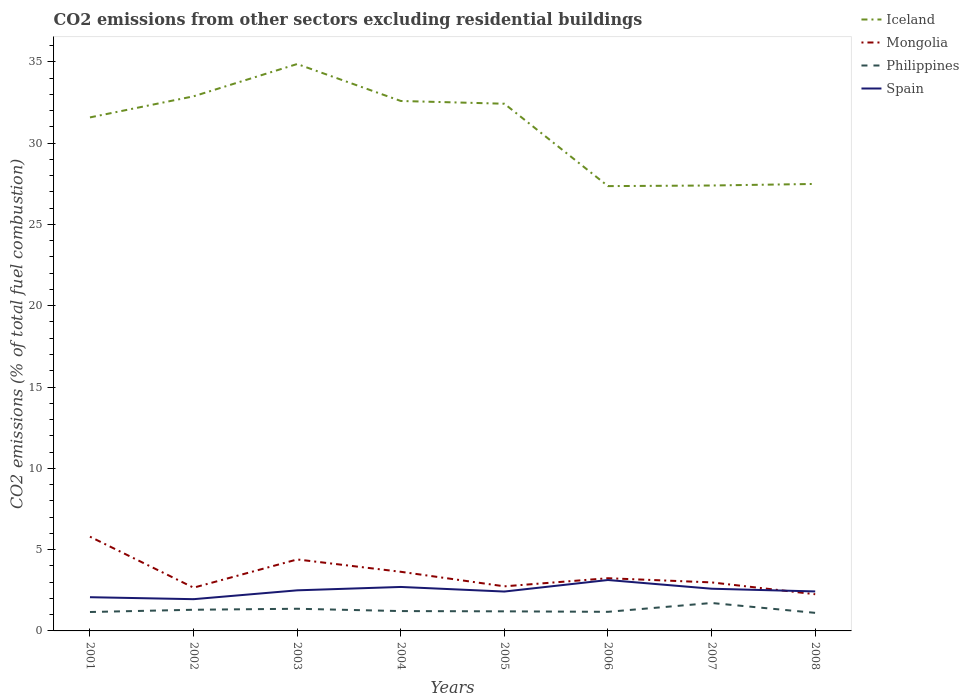How many different coloured lines are there?
Provide a short and direct response. 4. Does the line corresponding to Mongolia intersect with the line corresponding to Philippines?
Offer a terse response. No. Across all years, what is the maximum total CO2 emitted in Philippines?
Make the answer very short. 1.11. In which year was the total CO2 emitted in Philippines maximum?
Make the answer very short. 2008. What is the total total CO2 emitted in Philippines in the graph?
Provide a succinct answer. -0.51. What is the difference between the highest and the second highest total CO2 emitted in Iceland?
Your answer should be compact. 7.51. Is the total CO2 emitted in Spain strictly greater than the total CO2 emitted in Iceland over the years?
Give a very brief answer. Yes. How many lines are there?
Your response must be concise. 4. What is the difference between two consecutive major ticks on the Y-axis?
Give a very brief answer. 5. Does the graph contain any zero values?
Offer a terse response. No. Does the graph contain grids?
Provide a short and direct response. No. What is the title of the graph?
Give a very brief answer. CO2 emissions from other sectors excluding residential buildings. Does "Least developed countries" appear as one of the legend labels in the graph?
Provide a short and direct response. No. What is the label or title of the X-axis?
Your answer should be very brief. Years. What is the label or title of the Y-axis?
Your response must be concise. CO2 emissions (% of total fuel combustion). What is the CO2 emissions (% of total fuel combustion) of Iceland in 2001?
Offer a very short reply. 31.58. What is the CO2 emissions (% of total fuel combustion) of Mongolia in 2001?
Provide a succinct answer. 5.8. What is the CO2 emissions (% of total fuel combustion) in Philippines in 2001?
Keep it short and to the point. 1.16. What is the CO2 emissions (% of total fuel combustion) of Spain in 2001?
Provide a succinct answer. 2.07. What is the CO2 emissions (% of total fuel combustion) in Iceland in 2002?
Keep it short and to the point. 32.88. What is the CO2 emissions (% of total fuel combustion) in Mongolia in 2002?
Provide a short and direct response. 2.66. What is the CO2 emissions (% of total fuel combustion) in Philippines in 2002?
Give a very brief answer. 1.3. What is the CO2 emissions (% of total fuel combustion) in Spain in 2002?
Give a very brief answer. 1.95. What is the CO2 emissions (% of total fuel combustion) of Iceland in 2003?
Your answer should be compact. 34.86. What is the CO2 emissions (% of total fuel combustion) in Mongolia in 2003?
Keep it short and to the point. 4.4. What is the CO2 emissions (% of total fuel combustion) of Philippines in 2003?
Your answer should be compact. 1.36. What is the CO2 emissions (% of total fuel combustion) in Spain in 2003?
Ensure brevity in your answer.  2.5. What is the CO2 emissions (% of total fuel combustion) in Iceland in 2004?
Offer a terse response. 32.59. What is the CO2 emissions (% of total fuel combustion) of Mongolia in 2004?
Ensure brevity in your answer.  3.64. What is the CO2 emissions (% of total fuel combustion) in Philippines in 2004?
Your answer should be very brief. 1.22. What is the CO2 emissions (% of total fuel combustion) of Spain in 2004?
Provide a short and direct response. 2.7. What is the CO2 emissions (% of total fuel combustion) of Iceland in 2005?
Offer a terse response. 32.42. What is the CO2 emissions (% of total fuel combustion) in Mongolia in 2005?
Offer a very short reply. 2.74. What is the CO2 emissions (% of total fuel combustion) of Philippines in 2005?
Ensure brevity in your answer.  1.2. What is the CO2 emissions (% of total fuel combustion) of Spain in 2005?
Your answer should be very brief. 2.42. What is the CO2 emissions (% of total fuel combustion) in Iceland in 2006?
Give a very brief answer. 27.35. What is the CO2 emissions (% of total fuel combustion) of Mongolia in 2006?
Your answer should be very brief. 3.24. What is the CO2 emissions (% of total fuel combustion) of Philippines in 2006?
Keep it short and to the point. 1.17. What is the CO2 emissions (% of total fuel combustion) in Spain in 2006?
Your response must be concise. 3.13. What is the CO2 emissions (% of total fuel combustion) in Iceland in 2007?
Provide a short and direct response. 27.39. What is the CO2 emissions (% of total fuel combustion) in Mongolia in 2007?
Offer a terse response. 2.98. What is the CO2 emissions (% of total fuel combustion) in Philippines in 2007?
Offer a terse response. 1.72. What is the CO2 emissions (% of total fuel combustion) in Spain in 2007?
Your response must be concise. 2.6. What is the CO2 emissions (% of total fuel combustion) of Iceland in 2008?
Give a very brief answer. 27.49. What is the CO2 emissions (% of total fuel combustion) in Mongolia in 2008?
Provide a short and direct response. 2.26. What is the CO2 emissions (% of total fuel combustion) in Philippines in 2008?
Your answer should be compact. 1.11. What is the CO2 emissions (% of total fuel combustion) in Spain in 2008?
Give a very brief answer. 2.43. Across all years, what is the maximum CO2 emissions (% of total fuel combustion) in Iceland?
Offer a very short reply. 34.86. Across all years, what is the maximum CO2 emissions (% of total fuel combustion) of Mongolia?
Provide a succinct answer. 5.8. Across all years, what is the maximum CO2 emissions (% of total fuel combustion) in Philippines?
Your answer should be compact. 1.72. Across all years, what is the maximum CO2 emissions (% of total fuel combustion) in Spain?
Your response must be concise. 3.13. Across all years, what is the minimum CO2 emissions (% of total fuel combustion) in Iceland?
Offer a very short reply. 27.35. Across all years, what is the minimum CO2 emissions (% of total fuel combustion) in Mongolia?
Offer a terse response. 2.26. Across all years, what is the minimum CO2 emissions (% of total fuel combustion) in Philippines?
Keep it short and to the point. 1.11. Across all years, what is the minimum CO2 emissions (% of total fuel combustion) of Spain?
Your answer should be very brief. 1.95. What is the total CO2 emissions (% of total fuel combustion) in Iceland in the graph?
Your response must be concise. 246.56. What is the total CO2 emissions (% of total fuel combustion) of Mongolia in the graph?
Your answer should be very brief. 27.71. What is the total CO2 emissions (% of total fuel combustion) of Philippines in the graph?
Keep it short and to the point. 10.26. What is the total CO2 emissions (% of total fuel combustion) of Spain in the graph?
Your answer should be compact. 19.8. What is the difference between the CO2 emissions (% of total fuel combustion) of Iceland in 2001 and that in 2002?
Keep it short and to the point. -1.3. What is the difference between the CO2 emissions (% of total fuel combustion) of Mongolia in 2001 and that in 2002?
Your response must be concise. 3.14. What is the difference between the CO2 emissions (% of total fuel combustion) in Philippines in 2001 and that in 2002?
Provide a succinct answer. -0.14. What is the difference between the CO2 emissions (% of total fuel combustion) in Spain in 2001 and that in 2002?
Your response must be concise. 0.12. What is the difference between the CO2 emissions (% of total fuel combustion) in Iceland in 2001 and that in 2003?
Your response must be concise. -3.28. What is the difference between the CO2 emissions (% of total fuel combustion) in Mongolia in 2001 and that in 2003?
Your response must be concise. 1.4. What is the difference between the CO2 emissions (% of total fuel combustion) in Philippines in 2001 and that in 2003?
Give a very brief answer. -0.2. What is the difference between the CO2 emissions (% of total fuel combustion) of Spain in 2001 and that in 2003?
Ensure brevity in your answer.  -0.42. What is the difference between the CO2 emissions (% of total fuel combustion) in Iceland in 2001 and that in 2004?
Provide a short and direct response. -1.01. What is the difference between the CO2 emissions (% of total fuel combustion) in Mongolia in 2001 and that in 2004?
Give a very brief answer. 2.16. What is the difference between the CO2 emissions (% of total fuel combustion) in Philippines in 2001 and that in 2004?
Provide a succinct answer. -0.06. What is the difference between the CO2 emissions (% of total fuel combustion) of Spain in 2001 and that in 2004?
Your answer should be very brief. -0.63. What is the difference between the CO2 emissions (% of total fuel combustion) of Iceland in 2001 and that in 2005?
Offer a very short reply. -0.84. What is the difference between the CO2 emissions (% of total fuel combustion) in Mongolia in 2001 and that in 2005?
Make the answer very short. 3.05. What is the difference between the CO2 emissions (% of total fuel combustion) in Philippines in 2001 and that in 2005?
Provide a succinct answer. -0.04. What is the difference between the CO2 emissions (% of total fuel combustion) of Spain in 2001 and that in 2005?
Your answer should be very brief. -0.35. What is the difference between the CO2 emissions (% of total fuel combustion) of Iceland in 2001 and that in 2006?
Your answer should be compact. 4.22. What is the difference between the CO2 emissions (% of total fuel combustion) of Mongolia in 2001 and that in 2006?
Make the answer very short. 2.55. What is the difference between the CO2 emissions (% of total fuel combustion) in Philippines in 2001 and that in 2006?
Your answer should be compact. -0.01. What is the difference between the CO2 emissions (% of total fuel combustion) of Spain in 2001 and that in 2006?
Offer a very short reply. -1.06. What is the difference between the CO2 emissions (% of total fuel combustion) in Iceland in 2001 and that in 2007?
Give a very brief answer. 4.19. What is the difference between the CO2 emissions (% of total fuel combustion) of Mongolia in 2001 and that in 2007?
Your response must be concise. 2.81. What is the difference between the CO2 emissions (% of total fuel combustion) in Philippines in 2001 and that in 2007?
Offer a terse response. -0.55. What is the difference between the CO2 emissions (% of total fuel combustion) in Spain in 2001 and that in 2007?
Your response must be concise. -0.52. What is the difference between the CO2 emissions (% of total fuel combustion) in Iceland in 2001 and that in 2008?
Give a very brief answer. 4.09. What is the difference between the CO2 emissions (% of total fuel combustion) in Mongolia in 2001 and that in 2008?
Provide a succinct answer. 3.54. What is the difference between the CO2 emissions (% of total fuel combustion) in Philippines in 2001 and that in 2008?
Provide a succinct answer. 0.05. What is the difference between the CO2 emissions (% of total fuel combustion) in Spain in 2001 and that in 2008?
Provide a succinct answer. -0.35. What is the difference between the CO2 emissions (% of total fuel combustion) of Iceland in 2002 and that in 2003?
Offer a terse response. -1.99. What is the difference between the CO2 emissions (% of total fuel combustion) in Mongolia in 2002 and that in 2003?
Offer a very short reply. -1.74. What is the difference between the CO2 emissions (% of total fuel combustion) of Philippines in 2002 and that in 2003?
Your response must be concise. -0.06. What is the difference between the CO2 emissions (% of total fuel combustion) of Spain in 2002 and that in 2003?
Your response must be concise. -0.54. What is the difference between the CO2 emissions (% of total fuel combustion) of Iceland in 2002 and that in 2004?
Keep it short and to the point. 0.29. What is the difference between the CO2 emissions (% of total fuel combustion) in Mongolia in 2002 and that in 2004?
Offer a very short reply. -0.98. What is the difference between the CO2 emissions (% of total fuel combustion) of Philippines in 2002 and that in 2004?
Your answer should be very brief. 0.08. What is the difference between the CO2 emissions (% of total fuel combustion) in Spain in 2002 and that in 2004?
Give a very brief answer. -0.75. What is the difference between the CO2 emissions (% of total fuel combustion) of Iceland in 2002 and that in 2005?
Ensure brevity in your answer.  0.46. What is the difference between the CO2 emissions (% of total fuel combustion) in Mongolia in 2002 and that in 2005?
Give a very brief answer. -0.08. What is the difference between the CO2 emissions (% of total fuel combustion) in Philippines in 2002 and that in 2005?
Keep it short and to the point. 0.1. What is the difference between the CO2 emissions (% of total fuel combustion) in Spain in 2002 and that in 2005?
Give a very brief answer. -0.47. What is the difference between the CO2 emissions (% of total fuel combustion) of Iceland in 2002 and that in 2006?
Your response must be concise. 5.52. What is the difference between the CO2 emissions (% of total fuel combustion) of Mongolia in 2002 and that in 2006?
Your answer should be compact. -0.58. What is the difference between the CO2 emissions (% of total fuel combustion) in Philippines in 2002 and that in 2006?
Offer a very short reply. 0.13. What is the difference between the CO2 emissions (% of total fuel combustion) in Spain in 2002 and that in 2006?
Offer a very short reply. -1.18. What is the difference between the CO2 emissions (% of total fuel combustion) in Iceland in 2002 and that in 2007?
Your answer should be very brief. 5.49. What is the difference between the CO2 emissions (% of total fuel combustion) of Mongolia in 2002 and that in 2007?
Provide a short and direct response. -0.32. What is the difference between the CO2 emissions (% of total fuel combustion) in Philippines in 2002 and that in 2007?
Ensure brevity in your answer.  -0.42. What is the difference between the CO2 emissions (% of total fuel combustion) of Spain in 2002 and that in 2007?
Keep it short and to the point. -0.64. What is the difference between the CO2 emissions (% of total fuel combustion) of Iceland in 2002 and that in 2008?
Give a very brief answer. 5.39. What is the difference between the CO2 emissions (% of total fuel combustion) in Mongolia in 2002 and that in 2008?
Provide a short and direct response. 0.4. What is the difference between the CO2 emissions (% of total fuel combustion) of Philippines in 2002 and that in 2008?
Keep it short and to the point. 0.19. What is the difference between the CO2 emissions (% of total fuel combustion) in Spain in 2002 and that in 2008?
Your response must be concise. -0.48. What is the difference between the CO2 emissions (% of total fuel combustion) of Iceland in 2003 and that in 2004?
Provide a succinct answer. 2.27. What is the difference between the CO2 emissions (% of total fuel combustion) of Mongolia in 2003 and that in 2004?
Provide a succinct answer. 0.76. What is the difference between the CO2 emissions (% of total fuel combustion) of Philippines in 2003 and that in 2004?
Provide a short and direct response. 0.14. What is the difference between the CO2 emissions (% of total fuel combustion) of Spain in 2003 and that in 2004?
Your response must be concise. -0.21. What is the difference between the CO2 emissions (% of total fuel combustion) in Iceland in 2003 and that in 2005?
Give a very brief answer. 2.44. What is the difference between the CO2 emissions (% of total fuel combustion) of Mongolia in 2003 and that in 2005?
Your answer should be compact. 1.65. What is the difference between the CO2 emissions (% of total fuel combustion) in Philippines in 2003 and that in 2005?
Give a very brief answer. 0.16. What is the difference between the CO2 emissions (% of total fuel combustion) of Spain in 2003 and that in 2005?
Provide a succinct answer. 0.07. What is the difference between the CO2 emissions (% of total fuel combustion) in Iceland in 2003 and that in 2006?
Provide a succinct answer. 7.51. What is the difference between the CO2 emissions (% of total fuel combustion) in Mongolia in 2003 and that in 2006?
Give a very brief answer. 1.15. What is the difference between the CO2 emissions (% of total fuel combustion) of Philippines in 2003 and that in 2006?
Make the answer very short. 0.19. What is the difference between the CO2 emissions (% of total fuel combustion) in Spain in 2003 and that in 2006?
Your answer should be compact. -0.63. What is the difference between the CO2 emissions (% of total fuel combustion) of Iceland in 2003 and that in 2007?
Your answer should be very brief. 7.47. What is the difference between the CO2 emissions (% of total fuel combustion) of Mongolia in 2003 and that in 2007?
Offer a terse response. 1.41. What is the difference between the CO2 emissions (% of total fuel combustion) of Philippines in 2003 and that in 2007?
Keep it short and to the point. -0.35. What is the difference between the CO2 emissions (% of total fuel combustion) of Spain in 2003 and that in 2007?
Your response must be concise. -0.1. What is the difference between the CO2 emissions (% of total fuel combustion) in Iceland in 2003 and that in 2008?
Offer a terse response. 7.37. What is the difference between the CO2 emissions (% of total fuel combustion) in Mongolia in 2003 and that in 2008?
Your answer should be very brief. 2.14. What is the difference between the CO2 emissions (% of total fuel combustion) of Philippines in 2003 and that in 2008?
Make the answer very short. 0.25. What is the difference between the CO2 emissions (% of total fuel combustion) of Spain in 2003 and that in 2008?
Your response must be concise. 0.07. What is the difference between the CO2 emissions (% of total fuel combustion) in Iceland in 2004 and that in 2005?
Provide a short and direct response. 0.17. What is the difference between the CO2 emissions (% of total fuel combustion) in Mongolia in 2004 and that in 2005?
Your response must be concise. 0.89. What is the difference between the CO2 emissions (% of total fuel combustion) in Philippines in 2004 and that in 2005?
Your answer should be very brief. 0.02. What is the difference between the CO2 emissions (% of total fuel combustion) in Spain in 2004 and that in 2005?
Give a very brief answer. 0.28. What is the difference between the CO2 emissions (% of total fuel combustion) of Iceland in 2004 and that in 2006?
Provide a short and direct response. 5.24. What is the difference between the CO2 emissions (% of total fuel combustion) of Mongolia in 2004 and that in 2006?
Ensure brevity in your answer.  0.4. What is the difference between the CO2 emissions (% of total fuel combustion) in Philippines in 2004 and that in 2006?
Give a very brief answer. 0.05. What is the difference between the CO2 emissions (% of total fuel combustion) in Spain in 2004 and that in 2006?
Give a very brief answer. -0.43. What is the difference between the CO2 emissions (% of total fuel combustion) of Iceland in 2004 and that in 2007?
Provide a succinct answer. 5.2. What is the difference between the CO2 emissions (% of total fuel combustion) in Mongolia in 2004 and that in 2007?
Your answer should be very brief. 0.65. What is the difference between the CO2 emissions (% of total fuel combustion) in Philippines in 2004 and that in 2007?
Provide a short and direct response. -0.5. What is the difference between the CO2 emissions (% of total fuel combustion) in Spain in 2004 and that in 2007?
Give a very brief answer. 0.11. What is the difference between the CO2 emissions (% of total fuel combustion) in Iceland in 2004 and that in 2008?
Ensure brevity in your answer.  5.1. What is the difference between the CO2 emissions (% of total fuel combustion) in Mongolia in 2004 and that in 2008?
Your answer should be compact. 1.38. What is the difference between the CO2 emissions (% of total fuel combustion) in Philippines in 2004 and that in 2008?
Provide a short and direct response. 0.11. What is the difference between the CO2 emissions (% of total fuel combustion) in Spain in 2004 and that in 2008?
Offer a terse response. 0.28. What is the difference between the CO2 emissions (% of total fuel combustion) of Iceland in 2005 and that in 2006?
Give a very brief answer. 5.07. What is the difference between the CO2 emissions (% of total fuel combustion) in Mongolia in 2005 and that in 2006?
Keep it short and to the point. -0.5. What is the difference between the CO2 emissions (% of total fuel combustion) of Philippines in 2005 and that in 2006?
Make the answer very short. 0.03. What is the difference between the CO2 emissions (% of total fuel combustion) of Spain in 2005 and that in 2006?
Give a very brief answer. -0.71. What is the difference between the CO2 emissions (% of total fuel combustion) of Iceland in 2005 and that in 2007?
Your answer should be compact. 5.03. What is the difference between the CO2 emissions (% of total fuel combustion) of Mongolia in 2005 and that in 2007?
Keep it short and to the point. -0.24. What is the difference between the CO2 emissions (% of total fuel combustion) of Philippines in 2005 and that in 2007?
Your answer should be very brief. -0.51. What is the difference between the CO2 emissions (% of total fuel combustion) of Spain in 2005 and that in 2007?
Keep it short and to the point. -0.17. What is the difference between the CO2 emissions (% of total fuel combustion) in Iceland in 2005 and that in 2008?
Ensure brevity in your answer.  4.93. What is the difference between the CO2 emissions (% of total fuel combustion) in Mongolia in 2005 and that in 2008?
Provide a short and direct response. 0.49. What is the difference between the CO2 emissions (% of total fuel combustion) in Philippines in 2005 and that in 2008?
Your answer should be very brief. 0.09. What is the difference between the CO2 emissions (% of total fuel combustion) of Spain in 2005 and that in 2008?
Provide a succinct answer. -0.01. What is the difference between the CO2 emissions (% of total fuel combustion) of Iceland in 2006 and that in 2007?
Your answer should be very brief. -0.04. What is the difference between the CO2 emissions (% of total fuel combustion) of Mongolia in 2006 and that in 2007?
Your response must be concise. 0.26. What is the difference between the CO2 emissions (% of total fuel combustion) in Philippines in 2006 and that in 2007?
Offer a very short reply. -0.54. What is the difference between the CO2 emissions (% of total fuel combustion) of Spain in 2006 and that in 2007?
Keep it short and to the point. 0.54. What is the difference between the CO2 emissions (% of total fuel combustion) of Iceland in 2006 and that in 2008?
Your answer should be very brief. -0.13. What is the difference between the CO2 emissions (% of total fuel combustion) in Mongolia in 2006 and that in 2008?
Ensure brevity in your answer.  0.98. What is the difference between the CO2 emissions (% of total fuel combustion) in Philippines in 2006 and that in 2008?
Keep it short and to the point. 0.06. What is the difference between the CO2 emissions (% of total fuel combustion) of Spain in 2006 and that in 2008?
Your answer should be compact. 0.7. What is the difference between the CO2 emissions (% of total fuel combustion) in Iceland in 2007 and that in 2008?
Offer a very short reply. -0.1. What is the difference between the CO2 emissions (% of total fuel combustion) in Mongolia in 2007 and that in 2008?
Provide a short and direct response. 0.73. What is the difference between the CO2 emissions (% of total fuel combustion) in Philippines in 2007 and that in 2008?
Keep it short and to the point. 0.61. What is the difference between the CO2 emissions (% of total fuel combustion) of Spain in 2007 and that in 2008?
Give a very brief answer. 0.17. What is the difference between the CO2 emissions (% of total fuel combustion) in Iceland in 2001 and the CO2 emissions (% of total fuel combustion) in Mongolia in 2002?
Your answer should be very brief. 28.92. What is the difference between the CO2 emissions (% of total fuel combustion) in Iceland in 2001 and the CO2 emissions (% of total fuel combustion) in Philippines in 2002?
Provide a succinct answer. 30.28. What is the difference between the CO2 emissions (% of total fuel combustion) of Iceland in 2001 and the CO2 emissions (% of total fuel combustion) of Spain in 2002?
Make the answer very short. 29.63. What is the difference between the CO2 emissions (% of total fuel combustion) of Mongolia in 2001 and the CO2 emissions (% of total fuel combustion) of Philippines in 2002?
Make the answer very short. 4.49. What is the difference between the CO2 emissions (% of total fuel combustion) of Mongolia in 2001 and the CO2 emissions (% of total fuel combustion) of Spain in 2002?
Offer a very short reply. 3.84. What is the difference between the CO2 emissions (% of total fuel combustion) in Philippines in 2001 and the CO2 emissions (% of total fuel combustion) in Spain in 2002?
Your answer should be compact. -0.79. What is the difference between the CO2 emissions (% of total fuel combustion) of Iceland in 2001 and the CO2 emissions (% of total fuel combustion) of Mongolia in 2003?
Offer a very short reply. 27.18. What is the difference between the CO2 emissions (% of total fuel combustion) of Iceland in 2001 and the CO2 emissions (% of total fuel combustion) of Philippines in 2003?
Your answer should be compact. 30.22. What is the difference between the CO2 emissions (% of total fuel combustion) in Iceland in 2001 and the CO2 emissions (% of total fuel combustion) in Spain in 2003?
Ensure brevity in your answer.  29.08. What is the difference between the CO2 emissions (% of total fuel combustion) of Mongolia in 2001 and the CO2 emissions (% of total fuel combustion) of Philippines in 2003?
Make the answer very short. 4.43. What is the difference between the CO2 emissions (% of total fuel combustion) in Mongolia in 2001 and the CO2 emissions (% of total fuel combustion) in Spain in 2003?
Ensure brevity in your answer.  3.3. What is the difference between the CO2 emissions (% of total fuel combustion) in Philippines in 2001 and the CO2 emissions (% of total fuel combustion) in Spain in 2003?
Keep it short and to the point. -1.33. What is the difference between the CO2 emissions (% of total fuel combustion) of Iceland in 2001 and the CO2 emissions (% of total fuel combustion) of Mongolia in 2004?
Give a very brief answer. 27.94. What is the difference between the CO2 emissions (% of total fuel combustion) in Iceland in 2001 and the CO2 emissions (% of total fuel combustion) in Philippines in 2004?
Your answer should be very brief. 30.36. What is the difference between the CO2 emissions (% of total fuel combustion) in Iceland in 2001 and the CO2 emissions (% of total fuel combustion) in Spain in 2004?
Your answer should be compact. 28.87. What is the difference between the CO2 emissions (% of total fuel combustion) in Mongolia in 2001 and the CO2 emissions (% of total fuel combustion) in Philippines in 2004?
Provide a succinct answer. 4.57. What is the difference between the CO2 emissions (% of total fuel combustion) in Mongolia in 2001 and the CO2 emissions (% of total fuel combustion) in Spain in 2004?
Provide a succinct answer. 3.09. What is the difference between the CO2 emissions (% of total fuel combustion) in Philippines in 2001 and the CO2 emissions (% of total fuel combustion) in Spain in 2004?
Give a very brief answer. -1.54. What is the difference between the CO2 emissions (% of total fuel combustion) of Iceland in 2001 and the CO2 emissions (% of total fuel combustion) of Mongolia in 2005?
Your answer should be compact. 28.84. What is the difference between the CO2 emissions (% of total fuel combustion) in Iceland in 2001 and the CO2 emissions (% of total fuel combustion) in Philippines in 2005?
Offer a very short reply. 30.37. What is the difference between the CO2 emissions (% of total fuel combustion) in Iceland in 2001 and the CO2 emissions (% of total fuel combustion) in Spain in 2005?
Your response must be concise. 29.16. What is the difference between the CO2 emissions (% of total fuel combustion) of Mongolia in 2001 and the CO2 emissions (% of total fuel combustion) of Philippines in 2005?
Your answer should be very brief. 4.59. What is the difference between the CO2 emissions (% of total fuel combustion) in Mongolia in 2001 and the CO2 emissions (% of total fuel combustion) in Spain in 2005?
Provide a succinct answer. 3.37. What is the difference between the CO2 emissions (% of total fuel combustion) in Philippines in 2001 and the CO2 emissions (% of total fuel combustion) in Spain in 2005?
Make the answer very short. -1.26. What is the difference between the CO2 emissions (% of total fuel combustion) in Iceland in 2001 and the CO2 emissions (% of total fuel combustion) in Mongolia in 2006?
Offer a terse response. 28.34. What is the difference between the CO2 emissions (% of total fuel combustion) of Iceland in 2001 and the CO2 emissions (% of total fuel combustion) of Philippines in 2006?
Offer a very short reply. 30.4. What is the difference between the CO2 emissions (% of total fuel combustion) of Iceland in 2001 and the CO2 emissions (% of total fuel combustion) of Spain in 2006?
Your response must be concise. 28.45. What is the difference between the CO2 emissions (% of total fuel combustion) of Mongolia in 2001 and the CO2 emissions (% of total fuel combustion) of Philippines in 2006?
Your answer should be very brief. 4.62. What is the difference between the CO2 emissions (% of total fuel combustion) of Mongolia in 2001 and the CO2 emissions (% of total fuel combustion) of Spain in 2006?
Your answer should be compact. 2.66. What is the difference between the CO2 emissions (% of total fuel combustion) in Philippines in 2001 and the CO2 emissions (% of total fuel combustion) in Spain in 2006?
Your response must be concise. -1.97. What is the difference between the CO2 emissions (% of total fuel combustion) of Iceland in 2001 and the CO2 emissions (% of total fuel combustion) of Mongolia in 2007?
Your answer should be very brief. 28.6. What is the difference between the CO2 emissions (% of total fuel combustion) in Iceland in 2001 and the CO2 emissions (% of total fuel combustion) in Philippines in 2007?
Your response must be concise. 29.86. What is the difference between the CO2 emissions (% of total fuel combustion) of Iceland in 2001 and the CO2 emissions (% of total fuel combustion) of Spain in 2007?
Offer a very short reply. 28.98. What is the difference between the CO2 emissions (% of total fuel combustion) of Mongolia in 2001 and the CO2 emissions (% of total fuel combustion) of Philippines in 2007?
Keep it short and to the point. 4.08. What is the difference between the CO2 emissions (% of total fuel combustion) in Mongolia in 2001 and the CO2 emissions (% of total fuel combustion) in Spain in 2007?
Make the answer very short. 3.2. What is the difference between the CO2 emissions (% of total fuel combustion) in Philippines in 2001 and the CO2 emissions (% of total fuel combustion) in Spain in 2007?
Your response must be concise. -1.43. What is the difference between the CO2 emissions (% of total fuel combustion) of Iceland in 2001 and the CO2 emissions (% of total fuel combustion) of Mongolia in 2008?
Your response must be concise. 29.32. What is the difference between the CO2 emissions (% of total fuel combustion) of Iceland in 2001 and the CO2 emissions (% of total fuel combustion) of Philippines in 2008?
Offer a terse response. 30.47. What is the difference between the CO2 emissions (% of total fuel combustion) in Iceland in 2001 and the CO2 emissions (% of total fuel combustion) in Spain in 2008?
Your answer should be compact. 29.15. What is the difference between the CO2 emissions (% of total fuel combustion) of Mongolia in 2001 and the CO2 emissions (% of total fuel combustion) of Philippines in 2008?
Your answer should be compact. 4.68. What is the difference between the CO2 emissions (% of total fuel combustion) in Mongolia in 2001 and the CO2 emissions (% of total fuel combustion) in Spain in 2008?
Your answer should be compact. 3.37. What is the difference between the CO2 emissions (% of total fuel combustion) of Philippines in 2001 and the CO2 emissions (% of total fuel combustion) of Spain in 2008?
Give a very brief answer. -1.26. What is the difference between the CO2 emissions (% of total fuel combustion) of Iceland in 2002 and the CO2 emissions (% of total fuel combustion) of Mongolia in 2003?
Your answer should be very brief. 28.48. What is the difference between the CO2 emissions (% of total fuel combustion) in Iceland in 2002 and the CO2 emissions (% of total fuel combustion) in Philippines in 2003?
Give a very brief answer. 31.51. What is the difference between the CO2 emissions (% of total fuel combustion) of Iceland in 2002 and the CO2 emissions (% of total fuel combustion) of Spain in 2003?
Your response must be concise. 30.38. What is the difference between the CO2 emissions (% of total fuel combustion) in Mongolia in 2002 and the CO2 emissions (% of total fuel combustion) in Philippines in 2003?
Give a very brief answer. 1.3. What is the difference between the CO2 emissions (% of total fuel combustion) of Mongolia in 2002 and the CO2 emissions (% of total fuel combustion) of Spain in 2003?
Offer a very short reply. 0.16. What is the difference between the CO2 emissions (% of total fuel combustion) of Philippines in 2002 and the CO2 emissions (% of total fuel combustion) of Spain in 2003?
Your answer should be compact. -1.19. What is the difference between the CO2 emissions (% of total fuel combustion) in Iceland in 2002 and the CO2 emissions (% of total fuel combustion) in Mongolia in 2004?
Your answer should be compact. 29.24. What is the difference between the CO2 emissions (% of total fuel combustion) in Iceland in 2002 and the CO2 emissions (% of total fuel combustion) in Philippines in 2004?
Give a very brief answer. 31.66. What is the difference between the CO2 emissions (% of total fuel combustion) in Iceland in 2002 and the CO2 emissions (% of total fuel combustion) in Spain in 2004?
Ensure brevity in your answer.  30.17. What is the difference between the CO2 emissions (% of total fuel combustion) of Mongolia in 2002 and the CO2 emissions (% of total fuel combustion) of Philippines in 2004?
Offer a terse response. 1.44. What is the difference between the CO2 emissions (% of total fuel combustion) of Mongolia in 2002 and the CO2 emissions (% of total fuel combustion) of Spain in 2004?
Provide a succinct answer. -0.04. What is the difference between the CO2 emissions (% of total fuel combustion) in Philippines in 2002 and the CO2 emissions (% of total fuel combustion) in Spain in 2004?
Your answer should be very brief. -1.4. What is the difference between the CO2 emissions (% of total fuel combustion) of Iceland in 2002 and the CO2 emissions (% of total fuel combustion) of Mongolia in 2005?
Give a very brief answer. 30.13. What is the difference between the CO2 emissions (% of total fuel combustion) in Iceland in 2002 and the CO2 emissions (% of total fuel combustion) in Philippines in 2005?
Your answer should be compact. 31.67. What is the difference between the CO2 emissions (% of total fuel combustion) of Iceland in 2002 and the CO2 emissions (% of total fuel combustion) of Spain in 2005?
Offer a very short reply. 30.46. What is the difference between the CO2 emissions (% of total fuel combustion) in Mongolia in 2002 and the CO2 emissions (% of total fuel combustion) in Philippines in 2005?
Provide a succinct answer. 1.46. What is the difference between the CO2 emissions (% of total fuel combustion) in Mongolia in 2002 and the CO2 emissions (% of total fuel combustion) in Spain in 2005?
Provide a short and direct response. 0.24. What is the difference between the CO2 emissions (% of total fuel combustion) in Philippines in 2002 and the CO2 emissions (% of total fuel combustion) in Spain in 2005?
Provide a short and direct response. -1.12. What is the difference between the CO2 emissions (% of total fuel combustion) in Iceland in 2002 and the CO2 emissions (% of total fuel combustion) in Mongolia in 2006?
Provide a succinct answer. 29.64. What is the difference between the CO2 emissions (% of total fuel combustion) in Iceland in 2002 and the CO2 emissions (% of total fuel combustion) in Philippines in 2006?
Offer a terse response. 31.7. What is the difference between the CO2 emissions (% of total fuel combustion) of Iceland in 2002 and the CO2 emissions (% of total fuel combustion) of Spain in 2006?
Provide a succinct answer. 29.75. What is the difference between the CO2 emissions (% of total fuel combustion) of Mongolia in 2002 and the CO2 emissions (% of total fuel combustion) of Philippines in 2006?
Your response must be concise. 1.48. What is the difference between the CO2 emissions (% of total fuel combustion) of Mongolia in 2002 and the CO2 emissions (% of total fuel combustion) of Spain in 2006?
Give a very brief answer. -0.47. What is the difference between the CO2 emissions (% of total fuel combustion) of Philippines in 2002 and the CO2 emissions (% of total fuel combustion) of Spain in 2006?
Keep it short and to the point. -1.83. What is the difference between the CO2 emissions (% of total fuel combustion) of Iceland in 2002 and the CO2 emissions (% of total fuel combustion) of Mongolia in 2007?
Provide a succinct answer. 29.89. What is the difference between the CO2 emissions (% of total fuel combustion) in Iceland in 2002 and the CO2 emissions (% of total fuel combustion) in Philippines in 2007?
Your response must be concise. 31.16. What is the difference between the CO2 emissions (% of total fuel combustion) in Iceland in 2002 and the CO2 emissions (% of total fuel combustion) in Spain in 2007?
Give a very brief answer. 30.28. What is the difference between the CO2 emissions (% of total fuel combustion) of Mongolia in 2002 and the CO2 emissions (% of total fuel combustion) of Philippines in 2007?
Make the answer very short. 0.94. What is the difference between the CO2 emissions (% of total fuel combustion) in Mongolia in 2002 and the CO2 emissions (% of total fuel combustion) in Spain in 2007?
Offer a very short reply. 0.06. What is the difference between the CO2 emissions (% of total fuel combustion) in Philippines in 2002 and the CO2 emissions (% of total fuel combustion) in Spain in 2007?
Offer a very short reply. -1.29. What is the difference between the CO2 emissions (% of total fuel combustion) of Iceland in 2002 and the CO2 emissions (% of total fuel combustion) of Mongolia in 2008?
Your answer should be very brief. 30.62. What is the difference between the CO2 emissions (% of total fuel combustion) of Iceland in 2002 and the CO2 emissions (% of total fuel combustion) of Philippines in 2008?
Your answer should be compact. 31.77. What is the difference between the CO2 emissions (% of total fuel combustion) in Iceland in 2002 and the CO2 emissions (% of total fuel combustion) in Spain in 2008?
Keep it short and to the point. 30.45. What is the difference between the CO2 emissions (% of total fuel combustion) in Mongolia in 2002 and the CO2 emissions (% of total fuel combustion) in Philippines in 2008?
Give a very brief answer. 1.55. What is the difference between the CO2 emissions (% of total fuel combustion) of Mongolia in 2002 and the CO2 emissions (% of total fuel combustion) of Spain in 2008?
Ensure brevity in your answer.  0.23. What is the difference between the CO2 emissions (% of total fuel combustion) of Philippines in 2002 and the CO2 emissions (% of total fuel combustion) of Spain in 2008?
Your answer should be very brief. -1.13. What is the difference between the CO2 emissions (% of total fuel combustion) of Iceland in 2003 and the CO2 emissions (% of total fuel combustion) of Mongolia in 2004?
Offer a very short reply. 31.23. What is the difference between the CO2 emissions (% of total fuel combustion) in Iceland in 2003 and the CO2 emissions (% of total fuel combustion) in Philippines in 2004?
Your answer should be very brief. 33.64. What is the difference between the CO2 emissions (% of total fuel combustion) in Iceland in 2003 and the CO2 emissions (% of total fuel combustion) in Spain in 2004?
Provide a succinct answer. 32.16. What is the difference between the CO2 emissions (% of total fuel combustion) of Mongolia in 2003 and the CO2 emissions (% of total fuel combustion) of Philippines in 2004?
Keep it short and to the point. 3.17. What is the difference between the CO2 emissions (% of total fuel combustion) of Mongolia in 2003 and the CO2 emissions (% of total fuel combustion) of Spain in 2004?
Your answer should be very brief. 1.69. What is the difference between the CO2 emissions (% of total fuel combustion) of Philippines in 2003 and the CO2 emissions (% of total fuel combustion) of Spain in 2004?
Your answer should be compact. -1.34. What is the difference between the CO2 emissions (% of total fuel combustion) in Iceland in 2003 and the CO2 emissions (% of total fuel combustion) in Mongolia in 2005?
Keep it short and to the point. 32.12. What is the difference between the CO2 emissions (% of total fuel combustion) of Iceland in 2003 and the CO2 emissions (% of total fuel combustion) of Philippines in 2005?
Offer a very short reply. 33.66. What is the difference between the CO2 emissions (% of total fuel combustion) in Iceland in 2003 and the CO2 emissions (% of total fuel combustion) in Spain in 2005?
Keep it short and to the point. 32.44. What is the difference between the CO2 emissions (% of total fuel combustion) of Mongolia in 2003 and the CO2 emissions (% of total fuel combustion) of Philippines in 2005?
Your answer should be compact. 3.19. What is the difference between the CO2 emissions (% of total fuel combustion) of Mongolia in 2003 and the CO2 emissions (% of total fuel combustion) of Spain in 2005?
Your answer should be compact. 1.97. What is the difference between the CO2 emissions (% of total fuel combustion) in Philippines in 2003 and the CO2 emissions (% of total fuel combustion) in Spain in 2005?
Provide a succinct answer. -1.06. What is the difference between the CO2 emissions (% of total fuel combustion) of Iceland in 2003 and the CO2 emissions (% of total fuel combustion) of Mongolia in 2006?
Offer a terse response. 31.62. What is the difference between the CO2 emissions (% of total fuel combustion) of Iceland in 2003 and the CO2 emissions (% of total fuel combustion) of Philippines in 2006?
Provide a short and direct response. 33.69. What is the difference between the CO2 emissions (% of total fuel combustion) in Iceland in 2003 and the CO2 emissions (% of total fuel combustion) in Spain in 2006?
Make the answer very short. 31.73. What is the difference between the CO2 emissions (% of total fuel combustion) in Mongolia in 2003 and the CO2 emissions (% of total fuel combustion) in Philippines in 2006?
Your response must be concise. 3.22. What is the difference between the CO2 emissions (% of total fuel combustion) of Mongolia in 2003 and the CO2 emissions (% of total fuel combustion) of Spain in 2006?
Your answer should be very brief. 1.26. What is the difference between the CO2 emissions (% of total fuel combustion) in Philippines in 2003 and the CO2 emissions (% of total fuel combustion) in Spain in 2006?
Offer a very short reply. -1.77. What is the difference between the CO2 emissions (% of total fuel combustion) of Iceland in 2003 and the CO2 emissions (% of total fuel combustion) of Mongolia in 2007?
Provide a short and direct response. 31.88. What is the difference between the CO2 emissions (% of total fuel combustion) in Iceland in 2003 and the CO2 emissions (% of total fuel combustion) in Philippines in 2007?
Make the answer very short. 33.14. What is the difference between the CO2 emissions (% of total fuel combustion) of Iceland in 2003 and the CO2 emissions (% of total fuel combustion) of Spain in 2007?
Make the answer very short. 32.27. What is the difference between the CO2 emissions (% of total fuel combustion) in Mongolia in 2003 and the CO2 emissions (% of total fuel combustion) in Philippines in 2007?
Ensure brevity in your answer.  2.68. What is the difference between the CO2 emissions (% of total fuel combustion) of Mongolia in 2003 and the CO2 emissions (% of total fuel combustion) of Spain in 2007?
Give a very brief answer. 1.8. What is the difference between the CO2 emissions (% of total fuel combustion) of Philippines in 2003 and the CO2 emissions (% of total fuel combustion) of Spain in 2007?
Offer a very short reply. -1.23. What is the difference between the CO2 emissions (% of total fuel combustion) of Iceland in 2003 and the CO2 emissions (% of total fuel combustion) of Mongolia in 2008?
Provide a short and direct response. 32.61. What is the difference between the CO2 emissions (% of total fuel combustion) in Iceland in 2003 and the CO2 emissions (% of total fuel combustion) in Philippines in 2008?
Ensure brevity in your answer.  33.75. What is the difference between the CO2 emissions (% of total fuel combustion) in Iceland in 2003 and the CO2 emissions (% of total fuel combustion) in Spain in 2008?
Keep it short and to the point. 32.43. What is the difference between the CO2 emissions (% of total fuel combustion) of Mongolia in 2003 and the CO2 emissions (% of total fuel combustion) of Philippines in 2008?
Ensure brevity in your answer.  3.28. What is the difference between the CO2 emissions (% of total fuel combustion) of Mongolia in 2003 and the CO2 emissions (% of total fuel combustion) of Spain in 2008?
Keep it short and to the point. 1.97. What is the difference between the CO2 emissions (% of total fuel combustion) in Philippines in 2003 and the CO2 emissions (% of total fuel combustion) in Spain in 2008?
Your answer should be very brief. -1.06. What is the difference between the CO2 emissions (% of total fuel combustion) of Iceland in 2004 and the CO2 emissions (% of total fuel combustion) of Mongolia in 2005?
Your answer should be very brief. 29.85. What is the difference between the CO2 emissions (% of total fuel combustion) of Iceland in 2004 and the CO2 emissions (% of total fuel combustion) of Philippines in 2005?
Offer a terse response. 31.39. What is the difference between the CO2 emissions (% of total fuel combustion) of Iceland in 2004 and the CO2 emissions (% of total fuel combustion) of Spain in 2005?
Make the answer very short. 30.17. What is the difference between the CO2 emissions (% of total fuel combustion) of Mongolia in 2004 and the CO2 emissions (% of total fuel combustion) of Philippines in 2005?
Give a very brief answer. 2.43. What is the difference between the CO2 emissions (% of total fuel combustion) in Mongolia in 2004 and the CO2 emissions (% of total fuel combustion) in Spain in 2005?
Give a very brief answer. 1.21. What is the difference between the CO2 emissions (% of total fuel combustion) of Philippines in 2004 and the CO2 emissions (% of total fuel combustion) of Spain in 2005?
Keep it short and to the point. -1.2. What is the difference between the CO2 emissions (% of total fuel combustion) of Iceland in 2004 and the CO2 emissions (% of total fuel combustion) of Mongolia in 2006?
Ensure brevity in your answer.  29.35. What is the difference between the CO2 emissions (% of total fuel combustion) of Iceland in 2004 and the CO2 emissions (% of total fuel combustion) of Philippines in 2006?
Offer a terse response. 31.41. What is the difference between the CO2 emissions (% of total fuel combustion) in Iceland in 2004 and the CO2 emissions (% of total fuel combustion) in Spain in 2006?
Ensure brevity in your answer.  29.46. What is the difference between the CO2 emissions (% of total fuel combustion) of Mongolia in 2004 and the CO2 emissions (% of total fuel combustion) of Philippines in 2006?
Offer a terse response. 2.46. What is the difference between the CO2 emissions (% of total fuel combustion) of Mongolia in 2004 and the CO2 emissions (% of total fuel combustion) of Spain in 2006?
Offer a terse response. 0.51. What is the difference between the CO2 emissions (% of total fuel combustion) in Philippines in 2004 and the CO2 emissions (% of total fuel combustion) in Spain in 2006?
Your response must be concise. -1.91. What is the difference between the CO2 emissions (% of total fuel combustion) in Iceland in 2004 and the CO2 emissions (% of total fuel combustion) in Mongolia in 2007?
Offer a terse response. 29.61. What is the difference between the CO2 emissions (% of total fuel combustion) in Iceland in 2004 and the CO2 emissions (% of total fuel combustion) in Philippines in 2007?
Your answer should be compact. 30.87. What is the difference between the CO2 emissions (% of total fuel combustion) of Iceland in 2004 and the CO2 emissions (% of total fuel combustion) of Spain in 2007?
Provide a short and direct response. 29.99. What is the difference between the CO2 emissions (% of total fuel combustion) of Mongolia in 2004 and the CO2 emissions (% of total fuel combustion) of Philippines in 2007?
Your answer should be compact. 1.92. What is the difference between the CO2 emissions (% of total fuel combustion) of Mongolia in 2004 and the CO2 emissions (% of total fuel combustion) of Spain in 2007?
Offer a very short reply. 1.04. What is the difference between the CO2 emissions (% of total fuel combustion) in Philippines in 2004 and the CO2 emissions (% of total fuel combustion) in Spain in 2007?
Make the answer very short. -1.37. What is the difference between the CO2 emissions (% of total fuel combustion) in Iceland in 2004 and the CO2 emissions (% of total fuel combustion) in Mongolia in 2008?
Your response must be concise. 30.33. What is the difference between the CO2 emissions (% of total fuel combustion) of Iceland in 2004 and the CO2 emissions (% of total fuel combustion) of Philippines in 2008?
Offer a terse response. 31.48. What is the difference between the CO2 emissions (% of total fuel combustion) in Iceland in 2004 and the CO2 emissions (% of total fuel combustion) in Spain in 2008?
Your answer should be very brief. 30.16. What is the difference between the CO2 emissions (% of total fuel combustion) of Mongolia in 2004 and the CO2 emissions (% of total fuel combustion) of Philippines in 2008?
Your answer should be compact. 2.53. What is the difference between the CO2 emissions (% of total fuel combustion) in Mongolia in 2004 and the CO2 emissions (% of total fuel combustion) in Spain in 2008?
Make the answer very short. 1.21. What is the difference between the CO2 emissions (% of total fuel combustion) in Philippines in 2004 and the CO2 emissions (% of total fuel combustion) in Spain in 2008?
Your response must be concise. -1.21. What is the difference between the CO2 emissions (% of total fuel combustion) in Iceland in 2005 and the CO2 emissions (% of total fuel combustion) in Mongolia in 2006?
Your answer should be very brief. 29.18. What is the difference between the CO2 emissions (% of total fuel combustion) in Iceland in 2005 and the CO2 emissions (% of total fuel combustion) in Philippines in 2006?
Your answer should be compact. 31.25. What is the difference between the CO2 emissions (% of total fuel combustion) of Iceland in 2005 and the CO2 emissions (% of total fuel combustion) of Spain in 2006?
Provide a short and direct response. 29.29. What is the difference between the CO2 emissions (% of total fuel combustion) of Mongolia in 2005 and the CO2 emissions (% of total fuel combustion) of Philippines in 2006?
Make the answer very short. 1.57. What is the difference between the CO2 emissions (% of total fuel combustion) of Mongolia in 2005 and the CO2 emissions (% of total fuel combustion) of Spain in 2006?
Make the answer very short. -0.39. What is the difference between the CO2 emissions (% of total fuel combustion) in Philippines in 2005 and the CO2 emissions (% of total fuel combustion) in Spain in 2006?
Offer a terse response. -1.93. What is the difference between the CO2 emissions (% of total fuel combustion) of Iceland in 2005 and the CO2 emissions (% of total fuel combustion) of Mongolia in 2007?
Provide a succinct answer. 29.44. What is the difference between the CO2 emissions (% of total fuel combustion) in Iceland in 2005 and the CO2 emissions (% of total fuel combustion) in Philippines in 2007?
Offer a terse response. 30.7. What is the difference between the CO2 emissions (% of total fuel combustion) in Iceland in 2005 and the CO2 emissions (% of total fuel combustion) in Spain in 2007?
Offer a very short reply. 29.82. What is the difference between the CO2 emissions (% of total fuel combustion) of Mongolia in 2005 and the CO2 emissions (% of total fuel combustion) of Philippines in 2007?
Your answer should be compact. 1.02. What is the difference between the CO2 emissions (% of total fuel combustion) in Mongolia in 2005 and the CO2 emissions (% of total fuel combustion) in Spain in 2007?
Provide a short and direct response. 0.15. What is the difference between the CO2 emissions (% of total fuel combustion) of Philippines in 2005 and the CO2 emissions (% of total fuel combustion) of Spain in 2007?
Offer a very short reply. -1.39. What is the difference between the CO2 emissions (% of total fuel combustion) in Iceland in 2005 and the CO2 emissions (% of total fuel combustion) in Mongolia in 2008?
Ensure brevity in your answer.  30.16. What is the difference between the CO2 emissions (% of total fuel combustion) in Iceland in 2005 and the CO2 emissions (% of total fuel combustion) in Philippines in 2008?
Provide a short and direct response. 31.31. What is the difference between the CO2 emissions (% of total fuel combustion) of Iceland in 2005 and the CO2 emissions (% of total fuel combustion) of Spain in 2008?
Keep it short and to the point. 29.99. What is the difference between the CO2 emissions (% of total fuel combustion) of Mongolia in 2005 and the CO2 emissions (% of total fuel combustion) of Philippines in 2008?
Make the answer very short. 1.63. What is the difference between the CO2 emissions (% of total fuel combustion) of Mongolia in 2005 and the CO2 emissions (% of total fuel combustion) of Spain in 2008?
Provide a succinct answer. 0.31. What is the difference between the CO2 emissions (% of total fuel combustion) in Philippines in 2005 and the CO2 emissions (% of total fuel combustion) in Spain in 2008?
Keep it short and to the point. -1.22. What is the difference between the CO2 emissions (% of total fuel combustion) of Iceland in 2006 and the CO2 emissions (% of total fuel combustion) of Mongolia in 2007?
Give a very brief answer. 24.37. What is the difference between the CO2 emissions (% of total fuel combustion) of Iceland in 2006 and the CO2 emissions (% of total fuel combustion) of Philippines in 2007?
Provide a succinct answer. 25.64. What is the difference between the CO2 emissions (% of total fuel combustion) of Iceland in 2006 and the CO2 emissions (% of total fuel combustion) of Spain in 2007?
Ensure brevity in your answer.  24.76. What is the difference between the CO2 emissions (% of total fuel combustion) of Mongolia in 2006 and the CO2 emissions (% of total fuel combustion) of Philippines in 2007?
Provide a short and direct response. 1.52. What is the difference between the CO2 emissions (% of total fuel combustion) in Mongolia in 2006 and the CO2 emissions (% of total fuel combustion) in Spain in 2007?
Provide a short and direct response. 0.65. What is the difference between the CO2 emissions (% of total fuel combustion) in Philippines in 2006 and the CO2 emissions (% of total fuel combustion) in Spain in 2007?
Keep it short and to the point. -1.42. What is the difference between the CO2 emissions (% of total fuel combustion) of Iceland in 2006 and the CO2 emissions (% of total fuel combustion) of Mongolia in 2008?
Ensure brevity in your answer.  25.1. What is the difference between the CO2 emissions (% of total fuel combustion) in Iceland in 2006 and the CO2 emissions (% of total fuel combustion) in Philippines in 2008?
Provide a succinct answer. 26.24. What is the difference between the CO2 emissions (% of total fuel combustion) in Iceland in 2006 and the CO2 emissions (% of total fuel combustion) in Spain in 2008?
Give a very brief answer. 24.93. What is the difference between the CO2 emissions (% of total fuel combustion) of Mongolia in 2006 and the CO2 emissions (% of total fuel combustion) of Philippines in 2008?
Offer a very short reply. 2.13. What is the difference between the CO2 emissions (% of total fuel combustion) in Mongolia in 2006 and the CO2 emissions (% of total fuel combustion) in Spain in 2008?
Provide a short and direct response. 0.81. What is the difference between the CO2 emissions (% of total fuel combustion) in Philippines in 2006 and the CO2 emissions (% of total fuel combustion) in Spain in 2008?
Your response must be concise. -1.25. What is the difference between the CO2 emissions (% of total fuel combustion) in Iceland in 2007 and the CO2 emissions (% of total fuel combustion) in Mongolia in 2008?
Offer a very short reply. 25.14. What is the difference between the CO2 emissions (% of total fuel combustion) in Iceland in 2007 and the CO2 emissions (% of total fuel combustion) in Philippines in 2008?
Provide a succinct answer. 26.28. What is the difference between the CO2 emissions (% of total fuel combustion) in Iceland in 2007 and the CO2 emissions (% of total fuel combustion) in Spain in 2008?
Your answer should be compact. 24.96. What is the difference between the CO2 emissions (% of total fuel combustion) of Mongolia in 2007 and the CO2 emissions (% of total fuel combustion) of Philippines in 2008?
Provide a succinct answer. 1.87. What is the difference between the CO2 emissions (% of total fuel combustion) of Mongolia in 2007 and the CO2 emissions (% of total fuel combustion) of Spain in 2008?
Provide a short and direct response. 0.56. What is the difference between the CO2 emissions (% of total fuel combustion) in Philippines in 2007 and the CO2 emissions (% of total fuel combustion) in Spain in 2008?
Give a very brief answer. -0.71. What is the average CO2 emissions (% of total fuel combustion) in Iceland per year?
Provide a succinct answer. 30.82. What is the average CO2 emissions (% of total fuel combustion) of Mongolia per year?
Offer a terse response. 3.46. What is the average CO2 emissions (% of total fuel combustion) in Philippines per year?
Keep it short and to the point. 1.28. What is the average CO2 emissions (% of total fuel combustion) of Spain per year?
Your answer should be compact. 2.48. In the year 2001, what is the difference between the CO2 emissions (% of total fuel combustion) of Iceland and CO2 emissions (% of total fuel combustion) of Mongolia?
Provide a succinct answer. 25.78. In the year 2001, what is the difference between the CO2 emissions (% of total fuel combustion) of Iceland and CO2 emissions (% of total fuel combustion) of Philippines?
Keep it short and to the point. 30.42. In the year 2001, what is the difference between the CO2 emissions (% of total fuel combustion) of Iceland and CO2 emissions (% of total fuel combustion) of Spain?
Offer a very short reply. 29.51. In the year 2001, what is the difference between the CO2 emissions (% of total fuel combustion) of Mongolia and CO2 emissions (% of total fuel combustion) of Philippines?
Offer a terse response. 4.63. In the year 2001, what is the difference between the CO2 emissions (% of total fuel combustion) of Mongolia and CO2 emissions (% of total fuel combustion) of Spain?
Ensure brevity in your answer.  3.72. In the year 2001, what is the difference between the CO2 emissions (% of total fuel combustion) in Philippines and CO2 emissions (% of total fuel combustion) in Spain?
Offer a terse response. -0.91. In the year 2002, what is the difference between the CO2 emissions (% of total fuel combustion) in Iceland and CO2 emissions (% of total fuel combustion) in Mongolia?
Offer a terse response. 30.22. In the year 2002, what is the difference between the CO2 emissions (% of total fuel combustion) in Iceland and CO2 emissions (% of total fuel combustion) in Philippines?
Your response must be concise. 31.58. In the year 2002, what is the difference between the CO2 emissions (% of total fuel combustion) in Iceland and CO2 emissions (% of total fuel combustion) in Spain?
Your response must be concise. 30.92. In the year 2002, what is the difference between the CO2 emissions (% of total fuel combustion) in Mongolia and CO2 emissions (% of total fuel combustion) in Philippines?
Ensure brevity in your answer.  1.36. In the year 2002, what is the difference between the CO2 emissions (% of total fuel combustion) in Mongolia and CO2 emissions (% of total fuel combustion) in Spain?
Your answer should be compact. 0.71. In the year 2002, what is the difference between the CO2 emissions (% of total fuel combustion) of Philippines and CO2 emissions (% of total fuel combustion) of Spain?
Provide a short and direct response. -0.65. In the year 2003, what is the difference between the CO2 emissions (% of total fuel combustion) of Iceland and CO2 emissions (% of total fuel combustion) of Mongolia?
Make the answer very short. 30.47. In the year 2003, what is the difference between the CO2 emissions (% of total fuel combustion) in Iceland and CO2 emissions (% of total fuel combustion) in Philippines?
Provide a succinct answer. 33.5. In the year 2003, what is the difference between the CO2 emissions (% of total fuel combustion) in Iceland and CO2 emissions (% of total fuel combustion) in Spain?
Your answer should be compact. 32.37. In the year 2003, what is the difference between the CO2 emissions (% of total fuel combustion) in Mongolia and CO2 emissions (% of total fuel combustion) in Philippines?
Provide a succinct answer. 3.03. In the year 2003, what is the difference between the CO2 emissions (% of total fuel combustion) of Mongolia and CO2 emissions (% of total fuel combustion) of Spain?
Keep it short and to the point. 1.9. In the year 2003, what is the difference between the CO2 emissions (% of total fuel combustion) of Philippines and CO2 emissions (% of total fuel combustion) of Spain?
Provide a short and direct response. -1.13. In the year 2004, what is the difference between the CO2 emissions (% of total fuel combustion) of Iceland and CO2 emissions (% of total fuel combustion) of Mongolia?
Provide a succinct answer. 28.95. In the year 2004, what is the difference between the CO2 emissions (% of total fuel combustion) of Iceland and CO2 emissions (% of total fuel combustion) of Philippines?
Provide a succinct answer. 31.37. In the year 2004, what is the difference between the CO2 emissions (% of total fuel combustion) in Iceland and CO2 emissions (% of total fuel combustion) in Spain?
Keep it short and to the point. 29.89. In the year 2004, what is the difference between the CO2 emissions (% of total fuel combustion) of Mongolia and CO2 emissions (% of total fuel combustion) of Philippines?
Your answer should be compact. 2.42. In the year 2004, what is the difference between the CO2 emissions (% of total fuel combustion) of Mongolia and CO2 emissions (% of total fuel combustion) of Spain?
Keep it short and to the point. 0.93. In the year 2004, what is the difference between the CO2 emissions (% of total fuel combustion) in Philippines and CO2 emissions (% of total fuel combustion) in Spain?
Give a very brief answer. -1.48. In the year 2005, what is the difference between the CO2 emissions (% of total fuel combustion) in Iceland and CO2 emissions (% of total fuel combustion) in Mongolia?
Offer a terse response. 29.68. In the year 2005, what is the difference between the CO2 emissions (% of total fuel combustion) of Iceland and CO2 emissions (% of total fuel combustion) of Philippines?
Your response must be concise. 31.22. In the year 2005, what is the difference between the CO2 emissions (% of total fuel combustion) in Iceland and CO2 emissions (% of total fuel combustion) in Spain?
Give a very brief answer. 30. In the year 2005, what is the difference between the CO2 emissions (% of total fuel combustion) in Mongolia and CO2 emissions (% of total fuel combustion) in Philippines?
Provide a succinct answer. 1.54. In the year 2005, what is the difference between the CO2 emissions (% of total fuel combustion) in Mongolia and CO2 emissions (% of total fuel combustion) in Spain?
Your answer should be compact. 0.32. In the year 2005, what is the difference between the CO2 emissions (% of total fuel combustion) in Philippines and CO2 emissions (% of total fuel combustion) in Spain?
Keep it short and to the point. -1.22. In the year 2006, what is the difference between the CO2 emissions (% of total fuel combustion) of Iceland and CO2 emissions (% of total fuel combustion) of Mongolia?
Provide a succinct answer. 24.11. In the year 2006, what is the difference between the CO2 emissions (% of total fuel combustion) in Iceland and CO2 emissions (% of total fuel combustion) in Philippines?
Your answer should be very brief. 26.18. In the year 2006, what is the difference between the CO2 emissions (% of total fuel combustion) of Iceland and CO2 emissions (% of total fuel combustion) of Spain?
Your response must be concise. 24.22. In the year 2006, what is the difference between the CO2 emissions (% of total fuel combustion) in Mongolia and CO2 emissions (% of total fuel combustion) in Philippines?
Provide a short and direct response. 2.07. In the year 2006, what is the difference between the CO2 emissions (% of total fuel combustion) of Mongolia and CO2 emissions (% of total fuel combustion) of Spain?
Offer a terse response. 0.11. In the year 2006, what is the difference between the CO2 emissions (% of total fuel combustion) of Philippines and CO2 emissions (% of total fuel combustion) of Spain?
Provide a succinct answer. -1.96. In the year 2007, what is the difference between the CO2 emissions (% of total fuel combustion) of Iceland and CO2 emissions (% of total fuel combustion) of Mongolia?
Provide a succinct answer. 24.41. In the year 2007, what is the difference between the CO2 emissions (% of total fuel combustion) in Iceland and CO2 emissions (% of total fuel combustion) in Philippines?
Your answer should be very brief. 25.67. In the year 2007, what is the difference between the CO2 emissions (% of total fuel combustion) of Iceland and CO2 emissions (% of total fuel combustion) of Spain?
Your answer should be compact. 24.8. In the year 2007, what is the difference between the CO2 emissions (% of total fuel combustion) of Mongolia and CO2 emissions (% of total fuel combustion) of Philippines?
Offer a terse response. 1.27. In the year 2007, what is the difference between the CO2 emissions (% of total fuel combustion) in Mongolia and CO2 emissions (% of total fuel combustion) in Spain?
Offer a terse response. 0.39. In the year 2007, what is the difference between the CO2 emissions (% of total fuel combustion) of Philippines and CO2 emissions (% of total fuel combustion) of Spain?
Make the answer very short. -0.88. In the year 2008, what is the difference between the CO2 emissions (% of total fuel combustion) in Iceland and CO2 emissions (% of total fuel combustion) in Mongolia?
Ensure brevity in your answer.  25.23. In the year 2008, what is the difference between the CO2 emissions (% of total fuel combustion) of Iceland and CO2 emissions (% of total fuel combustion) of Philippines?
Provide a short and direct response. 26.38. In the year 2008, what is the difference between the CO2 emissions (% of total fuel combustion) of Iceland and CO2 emissions (% of total fuel combustion) of Spain?
Your response must be concise. 25.06. In the year 2008, what is the difference between the CO2 emissions (% of total fuel combustion) in Mongolia and CO2 emissions (% of total fuel combustion) in Philippines?
Your answer should be compact. 1.15. In the year 2008, what is the difference between the CO2 emissions (% of total fuel combustion) in Mongolia and CO2 emissions (% of total fuel combustion) in Spain?
Keep it short and to the point. -0.17. In the year 2008, what is the difference between the CO2 emissions (% of total fuel combustion) of Philippines and CO2 emissions (% of total fuel combustion) of Spain?
Make the answer very short. -1.32. What is the ratio of the CO2 emissions (% of total fuel combustion) of Iceland in 2001 to that in 2002?
Provide a succinct answer. 0.96. What is the ratio of the CO2 emissions (% of total fuel combustion) in Mongolia in 2001 to that in 2002?
Keep it short and to the point. 2.18. What is the ratio of the CO2 emissions (% of total fuel combustion) in Philippines in 2001 to that in 2002?
Provide a short and direct response. 0.89. What is the ratio of the CO2 emissions (% of total fuel combustion) of Spain in 2001 to that in 2002?
Provide a short and direct response. 1.06. What is the ratio of the CO2 emissions (% of total fuel combustion) of Iceland in 2001 to that in 2003?
Your response must be concise. 0.91. What is the ratio of the CO2 emissions (% of total fuel combustion) in Mongolia in 2001 to that in 2003?
Make the answer very short. 1.32. What is the ratio of the CO2 emissions (% of total fuel combustion) of Philippines in 2001 to that in 2003?
Keep it short and to the point. 0.85. What is the ratio of the CO2 emissions (% of total fuel combustion) of Spain in 2001 to that in 2003?
Provide a short and direct response. 0.83. What is the ratio of the CO2 emissions (% of total fuel combustion) of Mongolia in 2001 to that in 2004?
Keep it short and to the point. 1.59. What is the ratio of the CO2 emissions (% of total fuel combustion) in Philippines in 2001 to that in 2004?
Your answer should be very brief. 0.95. What is the ratio of the CO2 emissions (% of total fuel combustion) of Spain in 2001 to that in 2004?
Make the answer very short. 0.77. What is the ratio of the CO2 emissions (% of total fuel combustion) in Iceland in 2001 to that in 2005?
Offer a very short reply. 0.97. What is the ratio of the CO2 emissions (% of total fuel combustion) of Mongolia in 2001 to that in 2005?
Offer a terse response. 2.11. What is the ratio of the CO2 emissions (% of total fuel combustion) of Spain in 2001 to that in 2005?
Ensure brevity in your answer.  0.86. What is the ratio of the CO2 emissions (% of total fuel combustion) of Iceland in 2001 to that in 2006?
Give a very brief answer. 1.15. What is the ratio of the CO2 emissions (% of total fuel combustion) of Mongolia in 2001 to that in 2006?
Make the answer very short. 1.79. What is the ratio of the CO2 emissions (% of total fuel combustion) of Philippines in 2001 to that in 2006?
Provide a succinct answer. 0.99. What is the ratio of the CO2 emissions (% of total fuel combustion) in Spain in 2001 to that in 2006?
Offer a terse response. 0.66. What is the ratio of the CO2 emissions (% of total fuel combustion) of Iceland in 2001 to that in 2007?
Provide a succinct answer. 1.15. What is the ratio of the CO2 emissions (% of total fuel combustion) in Mongolia in 2001 to that in 2007?
Provide a succinct answer. 1.94. What is the ratio of the CO2 emissions (% of total fuel combustion) in Philippines in 2001 to that in 2007?
Ensure brevity in your answer.  0.68. What is the ratio of the CO2 emissions (% of total fuel combustion) of Spain in 2001 to that in 2007?
Your answer should be very brief. 0.8. What is the ratio of the CO2 emissions (% of total fuel combustion) of Iceland in 2001 to that in 2008?
Your answer should be very brief. 1.15. What is the ratio of the CO2 emissions (% of total fuel combustion) of Mongolia in 2001 to that in 2008?
Offer a very short reply. 2.57. What is the ratio of the CO2 emissions (% of total fuel combustion) of Philippines in 2001 to that in 2008?
Your response must be concise. 1.05. What is the ratio of the CO2 emissions (% of total fuel combustion) in Spain in 2001 to that in 2008?
Your response must be concise. 0.85. What is the ratio of the CO2 emissions (% of total fuel combustion) in Iceland in 2002 to that in 2003?
Offer a very short reply. 0.94. What is the ratio of the CO2 emissions (% of total fuel combustion) in Mongolia in 2002 to that in 2003?
Give a very brief answer. 0.61. What is the ratio of the CO2 emissions (% of total fuel combustion) of Philippines in 2002 to that in 2003?
Ensure brevity in your answer.  0.95. What is the ratio of the CO2 emissions (% of total fuel combustion) in Spain in 2002 to that in 2003?
Keep it short and to the point. 0.78. What is the ratio of the CO2 emissions (% of total fuel combustion) in Iceland in 2002 to that in 2004?
Provide a short and direct response. 1.01. What is the ratio of the CO2 emissions (% of total fuel combustion) in Mongolia in 2002 to that in 2004?
Your answer should be compact. 0.73. What is the ratio of the CO2 emissions (% of total fuel combustion) of Philippines in 2002 to that in 2004?
Ensure brevity in your answer.  1.07. What is the ratio of the CO2 emissions (% of total fuel combustion) of Spain in 2002 to that in 2004?
Your answer should be compact. 0.72. What is the ratio of the CO2 emissions (% of total fuel combustion) of Iceland in 2002 to that in 2005?
Make the answer very short. 1.01. What is the ratio of the CO2 emissions (% of total fuel combustion) of Mongolia in 2002 to that in 2005?
Provide a succinct answer. 0.97. What is the ratio of the CO2 emissions (% of total fuel combustion) of Philippines in 2002 to that in 2005?
Give a very brief answer. 1.08. What is the ratio of the CO2 emissions (% of total fuel combustion) of Spain in 2002 to that in 2005?
Your answer should be compact. 0.81. What is the ratio of the CO2 emissions (% of total fuel combustion) in Iceland in 2002 to that in 2006?
Ensure brevity in your answer.  1.2. What is the ratio of the CO2 emissions (% of total fuel combustion) of Mongolia in 2002 to that in 2006?
Provide a short and direct response. 0.82. What is the ratio of the CO2 emissions (% of total fuel combustion) in Philippines in 2002 to that in 2006?
Your answer should be compact. 1.11. What is the ratio of the CO2 emissions (% of total fuel combustion) in Spain in 2002 to that in 2006?
Make the answer very short. 0.62. What is the ratio of the CO2 emissions (% of total fuel combustion) of Iceland in 2002 to that in 2007?
Offer a very short reply. 1.2. What is the ratio of the CO2 emissions (% of total fuel combustion) of Mongolia in 2002 to that in 2007?
Provide a succinct answer. 0.89. What is the ratio of the CO2 emissions (% of total fuel combustion) in Philippines in 2002 to that in 2007?
Provide a succinct answer. 0.76. What is the ratio of the CO2 emissions (% of total fuel combustion) in Spain in 2002 to that in 2007?
Provide a succinct answer. 0.75. What is the ratio of the CO2 emissions (% of total fuel combustion) in Iceland in 2002 to that in 2008?
Give a very brief answer. 1.2. What is the ratio of the CO2 emissions (% of total fuel combustion) in Mongolia in 2002 to that in 2008?
Ensure brevity in your answer.  1.18. What is the ratio of the CO2 emissions (% of total fuel combustion) of Philippines in 2002 to that in 2008?
Make the answer very short. 1.17. What is the ratio of the CO2 emissions (% of total fuel combustion) in Spain in 2002 to that in 2008?
Provide a short and direct response. 0.8. What is the ratio of the CO2 emissions (% of total fuel combustion) of Iceland in 2003 to that in 2004?
Offer a very short reply. 1.07. What is the ratio of the CO2 emissions (% of total fuel combustion) of Mongolia in 2003 to that in 2004?
Give a very brief answer. 1.21. What is the ratio of the CO2 emissions (% of total fuel combustion) in Philippines in 2003 to that in 2004?
Your response must be concise. 1.12. What is the ratio of the CO2 emissions (% of total fuel combustion) in Iceland in 2003 to that in 2005?
Keep it short and to the point. 1.08. What is the ratio of the CO2 emissions (% of total fuel combustion) in Mongolia in 2003 to that in 2005?
Offer a very short reply. 1.6. What is the ratio of the CO2 emissions (% of total fuel combustion) in Philippines in 2003 to that in 2005?
Offer a terse response. 1.13. What is the ratio of the CO2 emissions (% of total fuel combustion) in Spain in 2003 to that in 2005?
Ensure brevity in your answer.  1.03. What is the ratio of the CO2 emissions (% of total fuel combustion) in Iceland in 2003 to that in 2006?
Give a very brief answer. 1.27. What is the ratio of the CO2 emissions (% of total fuel combustion) of Mongolia in 2003 to that in 2006?
Offer a terse response. 1.36. What is the ratio of the CO2 emissions (% of total fuel combustion) in Philippines in 2003 to that in 2006?
Keep it short and to the point. 1.16. What is the ratio of the CO2 emissions (% of total fuel combustion) of Spain in 2003 to that in 2006?
Make the answer very short. 0.8. What is the ratio of the CO2 emissions (% of total fuel combustion) of Iceland in 2003 to that in 2007?
Your answer should be compact. 1.27. What is the ratio of the CO2 emissions (% of total fuel combustion) of Mongolia in 2003 to that in 2007?
Keep it short and to the point. 1.47. What is the ratio of the CO2 emissions (% of total fuel combustion) in Philippines in 2003 to that in 2007?
Your answer should be very brief. 0.79. What is the ratio of the CO2 emissions (% of total fuel combustion) of Spain in 2003 to that in 2007?
Provide a succinct answer. 0.96. What is the ratio of the CO2 emissions (% of total fuel combustion) in Iceland in 2003 to that in 2008?
Your answer should be compact. 1.27. What is the ratio of the CO2 emissions (% of total fuel combustion) of Mongolia in 2003 to that in 2008?
Your answer should be very brief. 1.95. What is the ratio of the CO2 emissions (% of total fuel combustion) of Philippines in 2003 to that in 2008?
Ensure brevity in your answer.  1.23. What is the ratio of the CO2 emissions (% of total fuel combustion) in Spain in 2003 to that in 2008?
Make the answer very short. 1.03. What is the ratio of the CO2 emissions (% of total fuel combustion) in Iceland in 2004 to that in 2005?
Keep it short and to the point. 1.01. What is the ratio of the CO2 emissions (% of total fuel combustion) of Mongolia in 2004 to that in 2005?
Offer a terse response. 1.33. What is the ratio of the CO2 emissions (% of total fuel combustion) in Philippines in 2004 to that in 2005?
Your response must be concise. 1.01. What is the ratio of the CO2 emissions (% of total fuel combustion) of Spain in 2004 to that in 2005?
Offer a very short reply. 1.12. What is the ratio of the CO2 emissions (% of total fuel combustion) of Iceland in 2004 to that in 2006?
Provide a short and direct response. 1.19. What is the ratio of the CO2 emissions (% of total fuel combustion) in Mongolia in 2004 to that in 2006?
Ensure brevity in your answer.  1.12. What is the ratio of the CO2 emissions (% of total fuel combustion) of Philippines in 2004 to that in 2006?
Provide a succinct answer. 1.04. What is the ratio of the CO2 emissions (% of total fuel combustion) of Spain in 2004 to that in 2006?
Keep it short and to the point. 0.86. What is the ratio of the CO2 emissions (% of total fuel combustion) of Iceland in 2004 to that in 2007?
Make the answer very short. 1.19. What is the ratio of the CO2 emissions (% of total fuel combustion) of Mongolia in 2004 to that in 2007?
Offer a terse response. 1.22. What is the ratio of the CO2 emissions (% of total fuel combustion) in Philippines in 2004 to that in 2007?
Make the answer very short. 0.71. What is the ratio of the CO2 emissions (% of total fuel combustion) of Spain in 2004 to that in 2007?
Provide a succinct answer. 1.04. What is the ratio of the CO2 emissions (% of total fuel combustion) of Iceland in 2004 to that in 2008?
Ensure brevity in your answer.  1.19. What is the ratio of the CO2 emissions (% of total fuel combustion) in Mongolia in 2004 to that in 2008?
Keep it short and to the point. 1.61. What is the ratio of the CO2 emissions (% of total fuel combustion) of Philippines in 2004 to that in 2008?
Provide a succinct answer. 1.1. What is the ratio of the CO2 emissions (% of total fuel combustion) of Spain in 2004 to that in 2008?
Your answer should be compact. 1.11. What is the ratio of the CO2 emissions (% of total fuel combustion) of Iceland in 2005 to that in 2006?
Offer a very short reply. 1.19. What is the ratio of the CO2 emissions (% of total fuel combustion) of Mongolia in 2005 to that in 2006?
Give a very brief answer. 0.85. What is the ratio of the CO2 emissions (% of total fuel combustion) of Philippines in 2005 to that in 2006?
Provide a succinct answer. 1.03. What is the ratio of the CO2 emissions (% of total fuel combustion) of Spain in 2005 to that in 2006?
Provide a succinct answer. 0.77. What is the ratio of the CO2 emissions (% of total fuel combustion) of Iceland in 2005 to that in 2007?
Offer a very short reply. 1.18. What is the ratio of the CO2 emissions (% of total fuel combustion) in Mongolia in 2005 to that in 2007?
Your response must be concise. 0.92. What is the ratio of the CO2 emissions (% of total fuel combustion) of Philippines in 2005 to that in 2007?
Keep it short and to the point. 0.7. What is the ratio of the CO2 emissions (% of total fuel combustion) in Spain in 2005 to that in 2007?
Offer a very short reply. 0.93. What is the ratio of the CO2 emissions (% of total fuel combustion) of Iceland in 2005 to that in 2008?
Keep it short and to the point. 1.18. What is the ratio of the CO2 emissions (% of total fuel combustion) in Mongolia in 2005 to that in 2008?
Make the answer very short. 1.22. What is the ratio of the CO2 emissions (% of total fuel combustion) in Philippines in 2005 to that in 2008?
Provide a short and direct response. 1.08. What is the ratio of the CO2 emissions (% of total fuel combustion) of Spain in 2005 to that in 2008?
Ensure brevity in your answer.  1. What is the ratio of the CO2 emissions (% of total fuel combustion) of Iceland in 2006 to that in 2007?
Offer a very short reply. 1. What is the ratio of the CO2 emissions (% of total fuel combustion) in Mongolia in 2006 to that in 2007?
Keep it short and to the point. 1.09. What is the ratio of the CO2 emissions (% of total fuel combustion) of Philippines in 2006 to that in 2007?
Provide a short and direct response. 0.68. What is the ratio of the CO2 emissions (% of total fuel combustion) of Spain in 2006 to that in 2007?
Provide a succinct answer. 1.21. What is the ratio of the CO2 emissions (% of total fuel combustion) in Mongolia in 2006 to that in 2008?
Give a very brief answer. 1.44. What is the ratio of the CO2 emissions (% of total fuel combustion) in Philippines in 2006 to that in 2008?
Provide a succinct answer. 1.06. What is the ratio of the CO2 emissions (% of total fuel combustion) of Spain in 2006 to that in 2008?
Offer a very short reply. 1.29. What is the ratio of the CO2 emissions (% of total fuel combustion) in Mongolia in 2007 to that in 2008?
Keep it short and to the point. 1.32. What is the ratio of the CO2 emissions (% of total fuel combustion) of Philippines in 2007 to that in 2008?
Make the answer very short. 1.55. What is the ratio of the CO2 emissions (% of total fuel combustion) of Spain in 2007 to that in 2008?
Give a very brief answer. 1.07. What is the difference between the highest and the second highest CO2 emissions (% of total fuel combustion) in Iceland?
Offer a terse response. 1.99. What is the difference between the highest and the second highest CO2 emissions (% of total fuel combustion) of Mongolia?
Your answer should be very brief. 1.4. What is the difference between the highest and the second highest CO2 emissions (% of total fuel combustion) in Philippines?
Your response must be concise. 0.35. What is the difference between the highest and the second highest CO2 emissions (% of total fuel combustion) of Spain?
Make the answer very short. 0.43. What is the difference between the highest and the lowest CO2 emissions (% of total fuel combustion) in Iceland?
Your answer should be compact. 7.51. What is the difference between the highest and the lowest CO2 emissions (% of total fuel combustion) of Mongolia?
Provide a short and direct response. 3.54. What is the difference between the highest and the lowest CO2 emissions (% of total fuel combustion) of Philippines?
Your response must be concise. 0.61. What is the difference between the highest and the lowest CO2 emissions (% of total fuel combustion) in Spain?
Keep it short and to the point. 1.18. 